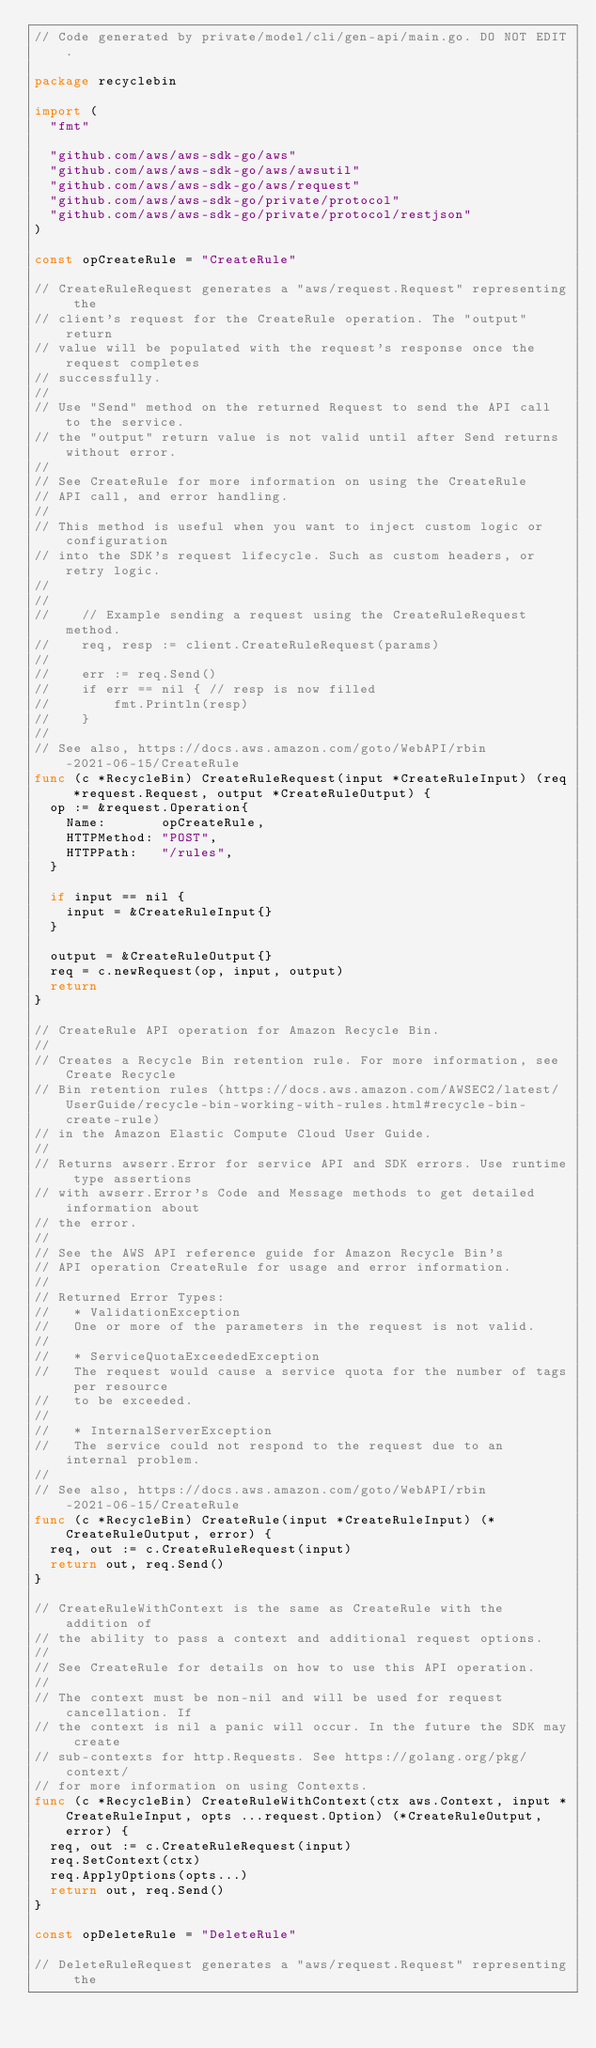Convert code to text. <code><loc_0><loc_0><loc_500><loc_500><_Go_>// Code generated by private/model/cli/gen-api/main.go. DO NOT EDIT.

package recyclebin

import (
	"fmt"

	"github.com/aws/aws-sdk-go/aws"
	"github.com/aws/aws-sdk-go/aws/awsutil"
	"github.com/aws/aws-sdk-go/aws/request"
	"github.com/aws/aws-sdk-go/private/protocol"
	"github.com/aws/aws-sdk-go/private/protocol/restjson"
)

const opCreateRule = "CreateRule"

// CreateRuleRequest generates a "aws/request.Request" representing the
// client's request for the CreateRule operation. The "output" return
// value will be populated with the request's response once the request completes
// successfully.
//
// Use "Send" method on the returned Request to send the API call to the service.
// the "output" return value is not valid until after Send returns without error.
//
// See CreateRule for more information on using the CreateRule
// API call, and error handling.
//
// This method is useful when you want to inject custom logic or configuration
// into the SDK's request lifecycle. Such as custom headers, or retry logic.
//
//
//    // Example sending a request using the CreateRuleRequest method.
//    req, resp := client.CreateRuleRequest(params)
//
//    err := req.Send()
//    if err == nil { // resp is now filled
//        fmt.Println(resp)
//    }
//
// See also, https://docs.aws.amazon.com/goto/WebAPI/rbin-2021-06-15/CreateRule
func (c *RecycleBin) CreateRuleRequest(input *CreateRuleInput) (req *request.Request, output *CreateRuleOutput) {
	op := &request.Operation{
		Name:       opCreateRule,
		HTTPMethod: "POST",
		HTTPPath:   "/rules",
	}

	if input == nil {
		input = &CreateRuleInput{}
	}

	output = &CreateRuleOutput{}
	req = c.newRequest(op, input, output)
	return
}

// CreateRule API operation for Amazon Recycle Bin.
//
// Creates a Recycle Bin retention rule. For more information, see Create Recycle
// Bin retention rules (https://docs.aws.amazon.com/AWSEC2/latest/UserGuide/recycle-bin-working-with-rules.html#recycle-bin-create-rule)
// in the Amazon Elastic Compute Cloud User Guide.
//
// Returns awserr.Error for service API and SDK errors. Use runtime type assertions
// with awserr.Error's Code and Message methods to get detailed information about
// the error.
//
// See the AWS API reference guide for Amazon Recycle Bin's
// API operation CreateRule for usage and error information.
//
// Returned Error Types:
//   * ValidationException
//   One or more of the parameters in the request is not valid.
//
//   * ServiceQuotaExceededException
//   The request would cause a service quota for the number of tags per resource
//   to be exceeded.
//
//   * InternalServerException
//   The service could not respond to the request due to an internal problem.
//
// See also, https://docs.aws.amazon.com/goto/WebAPI/rbin-2021-06-15/CreateRule
func (c *RecycleBin) CreateRule(input *CreateRuleInput) (*CreateRuleOutput, error) {
	req, out := c.CreateRuleRequest(input)
	return out, req.Send()
}

// CreateRuleWithContext is the same as CreateRule with the addition of
// the ability to pass a context and additional request options.
//
// See CreateRule for details on how to use this API operation.
//
// The context must be non-nil and will be used for request cancellation. If
// the context is nil a panic will occur. In the future the SDK may create
// sub-contexts for http.Requests. See https://golang.org/pkg/context/
// for more information on using Contexts.
func (c *RecycleBin) CreateRuleWithContext(ctx aws.Context, input *CreateRuleInput, opts ...request.Option) (*CreateRuleOutput, error) {
	req, out := c.CreateRuleRequest(input)
	req.SetContext(ctx)
	req.ApplyOptions(opts...)
	return out, req.Send()
}

const opDeleteRule = "DeleteRule"

// DeleteRuleRequest generates a "aws/request.Request" representing the</code> 